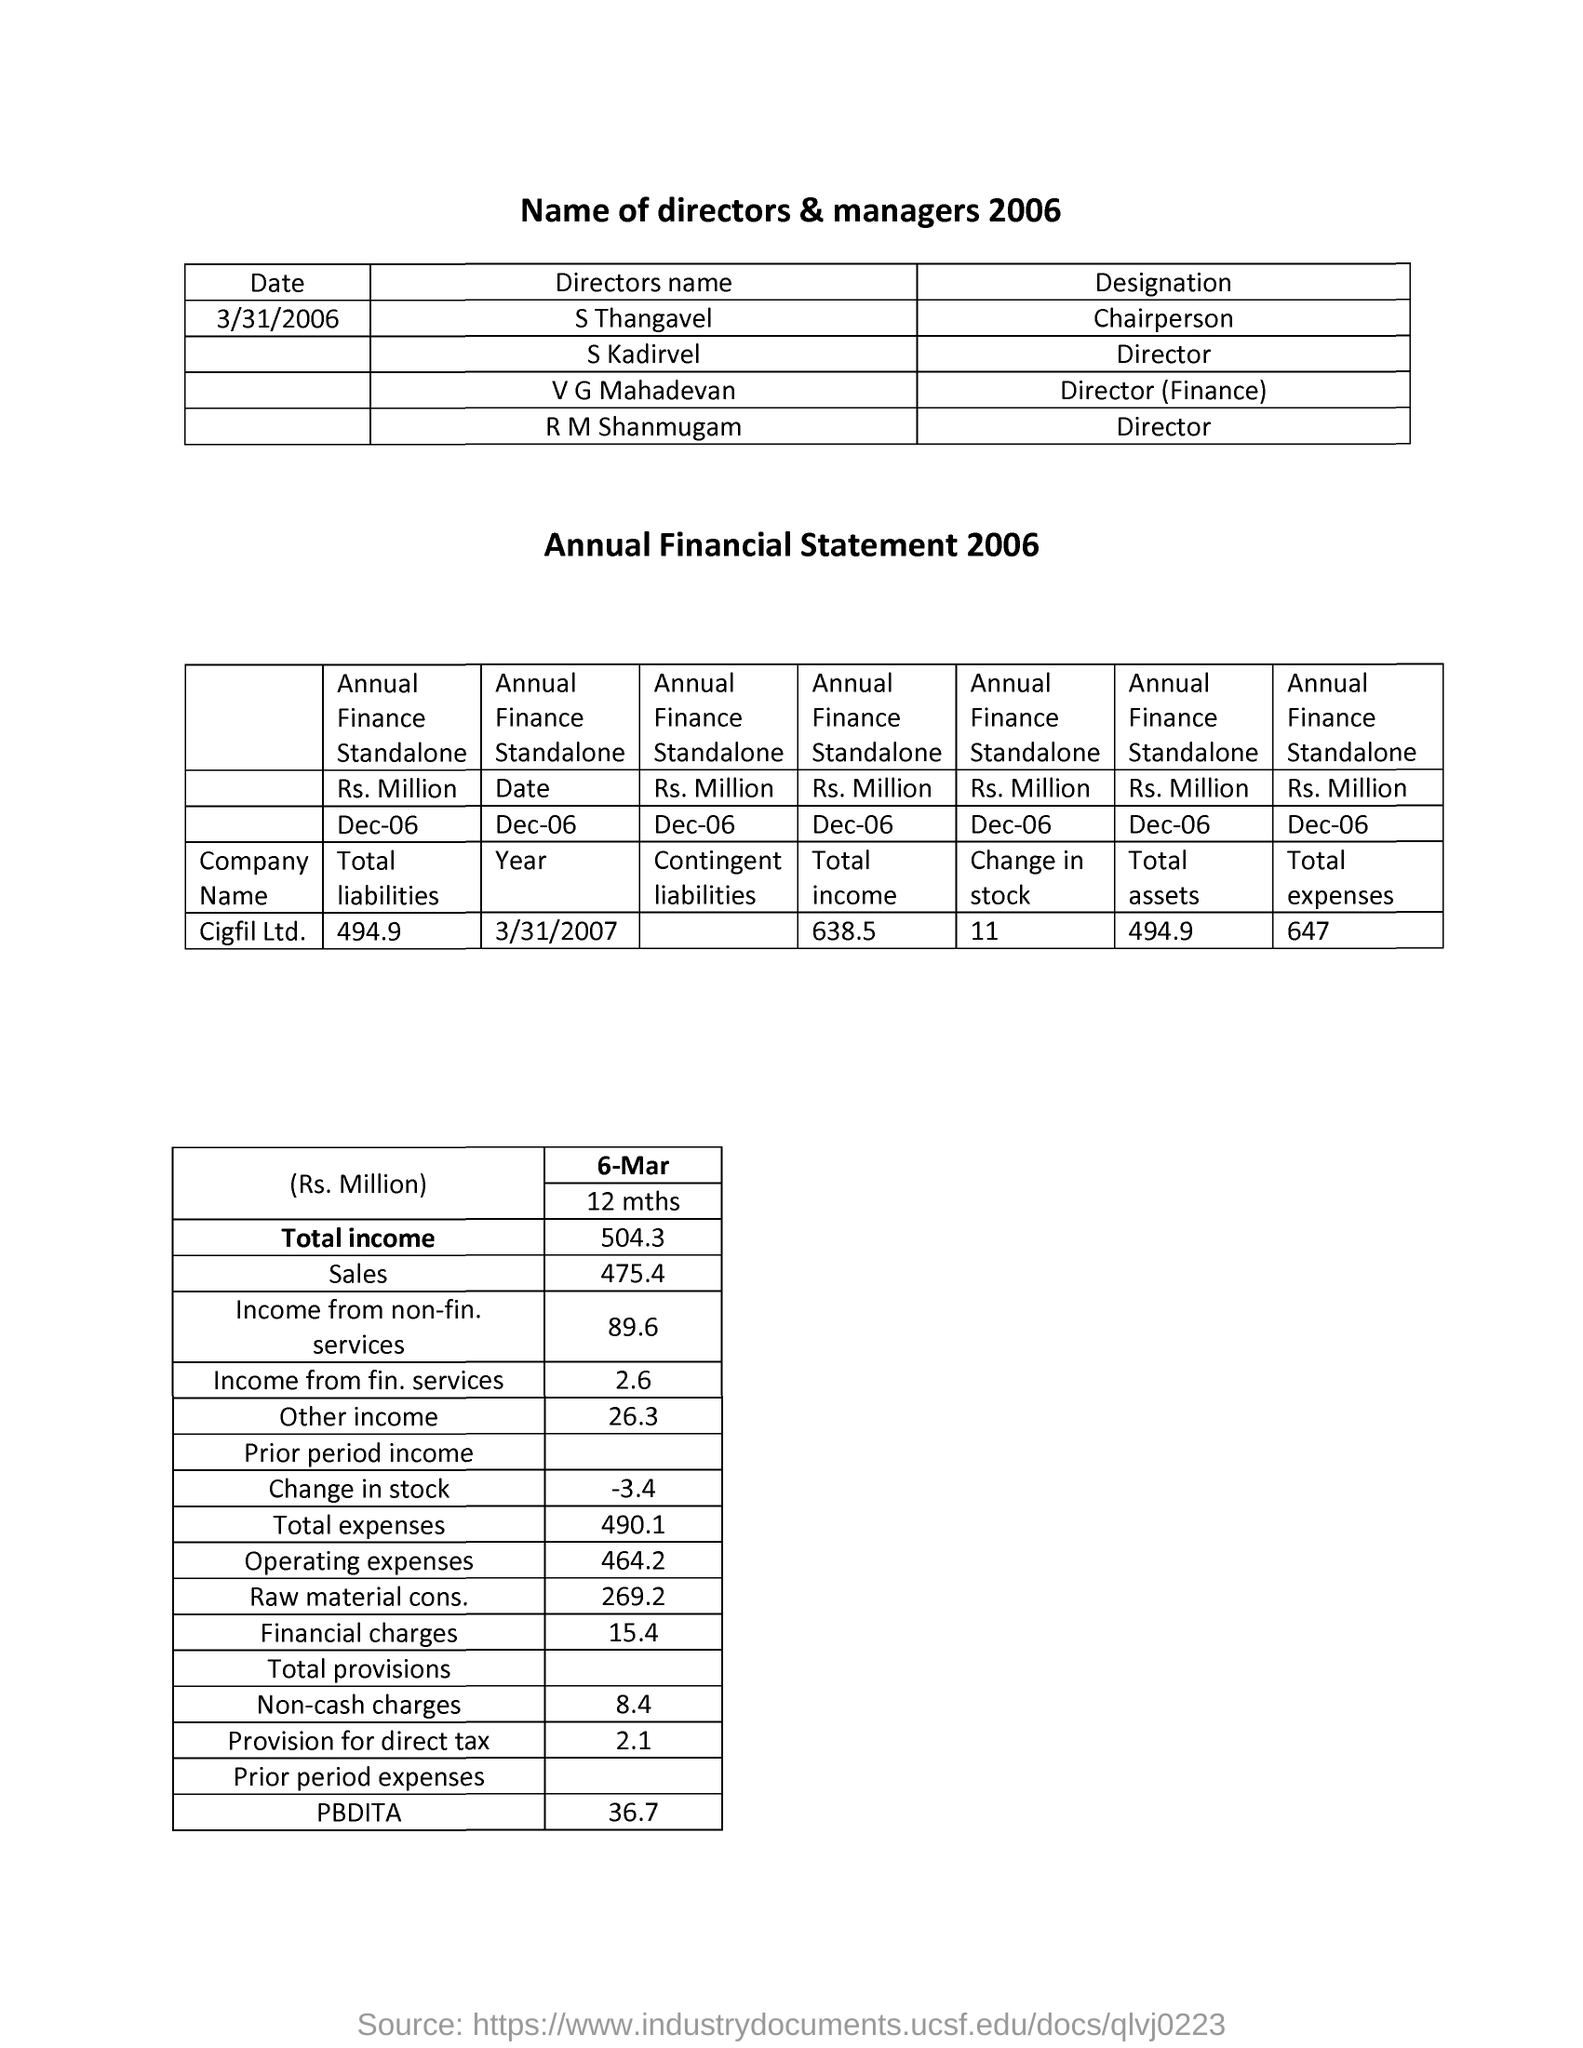List a handful of essential elements in this visual. S Kardivel is the Director of a certain organization or company. S Thangavel is the Chairperson of the organization. The Director of Finance is V G Mahadevan. 